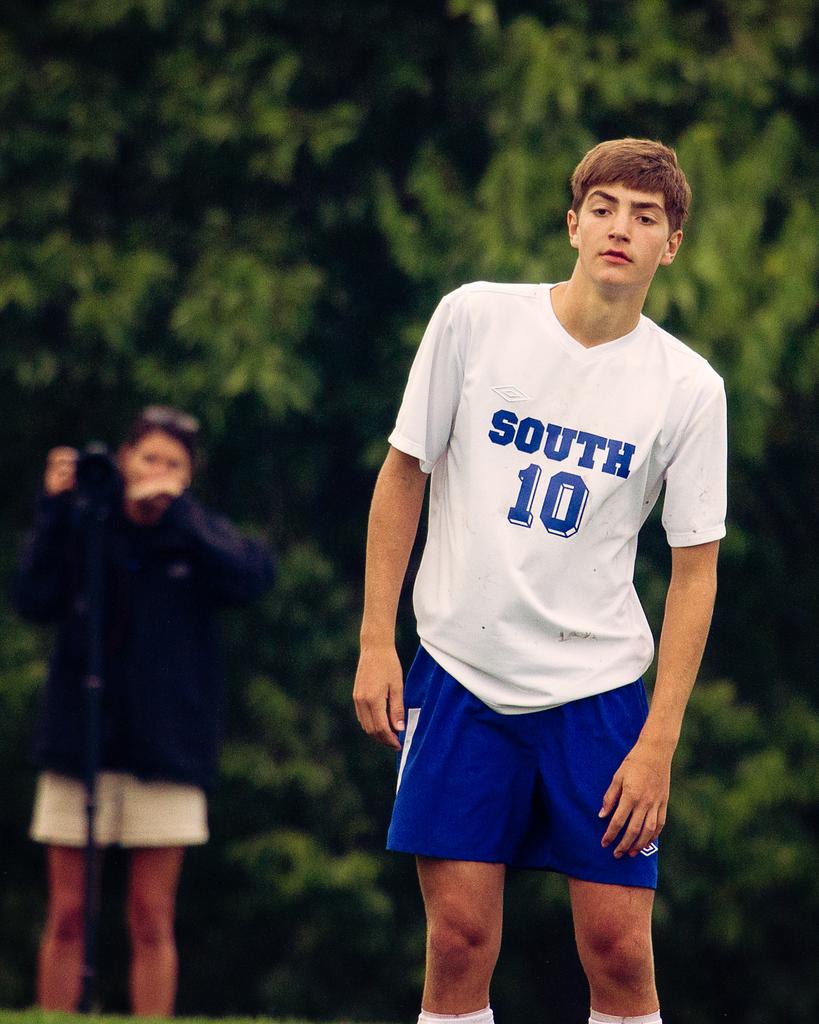What direction is the opposite of the direction written on this person's shirt?
Give a very brief answer. North. 